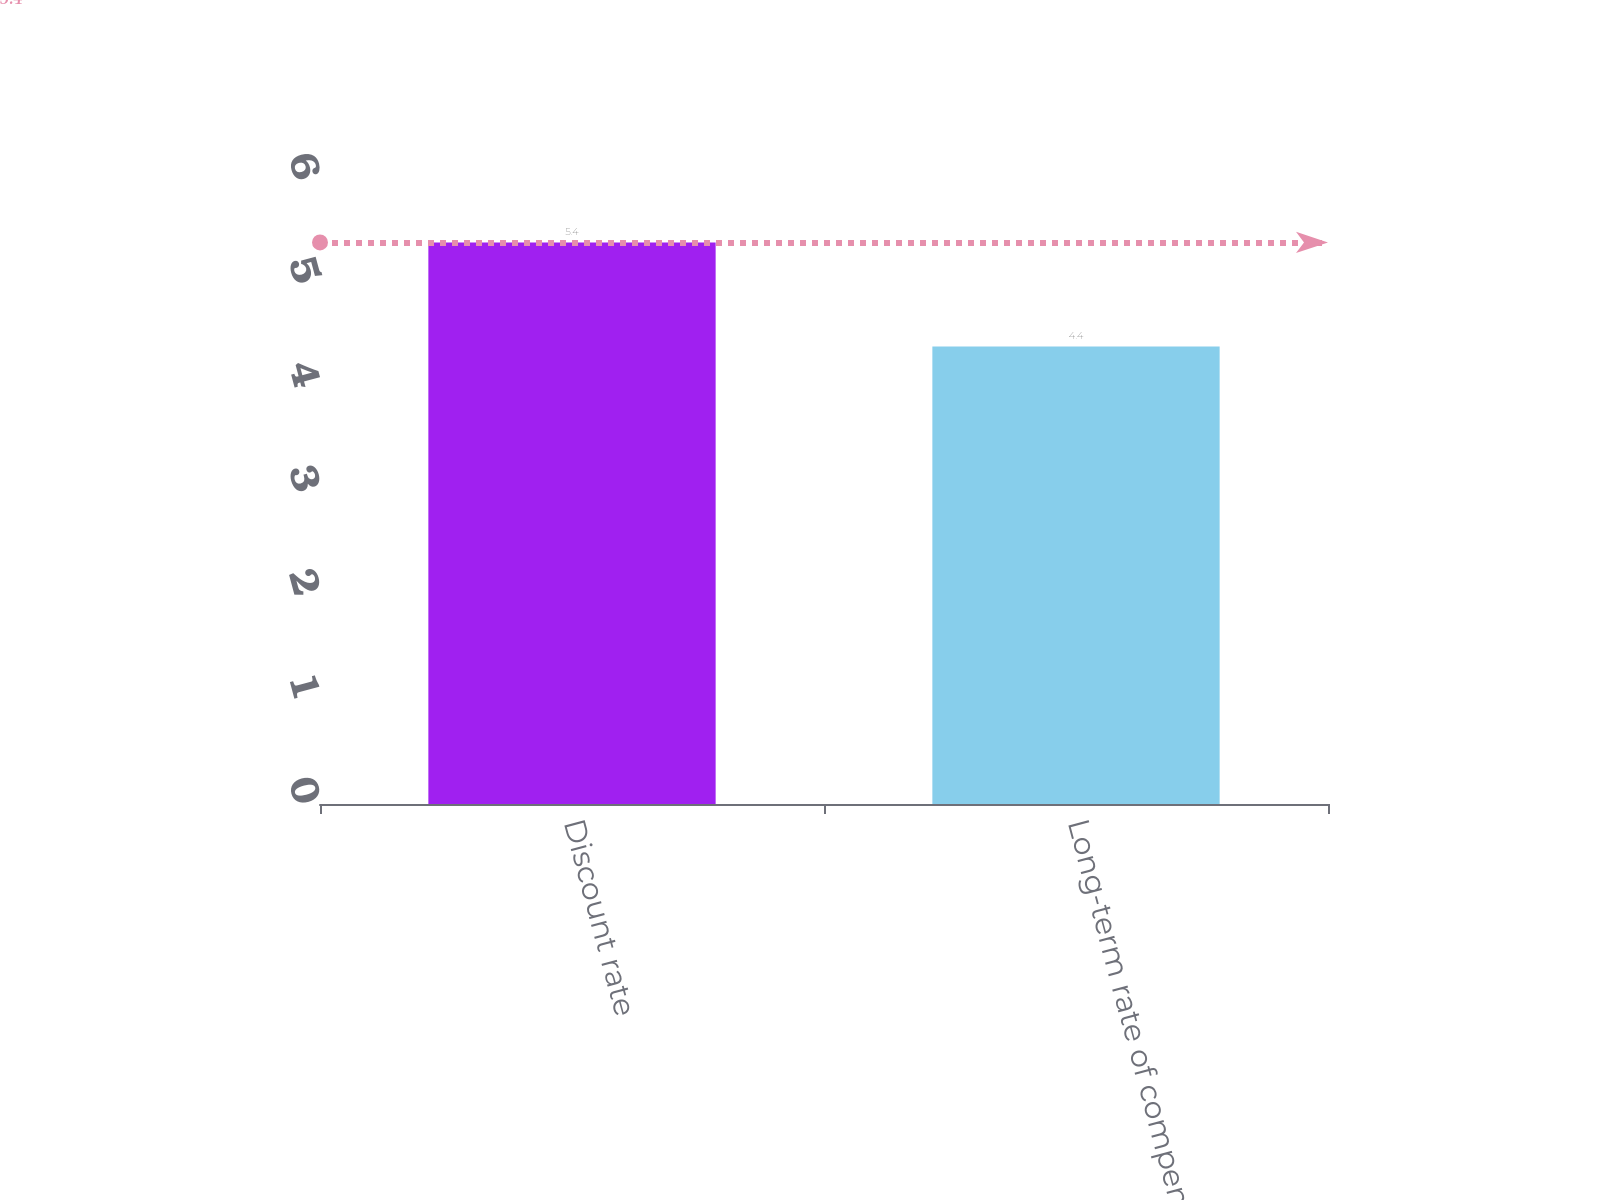Convert chart. <chart><loc_0><loc_0><loc_500><loc_500><bar_chart><fcel>Discount rate<fcel>Long-term rate of compensation<nl><fcel>5.4<fcel>4.4<nl></chart> 